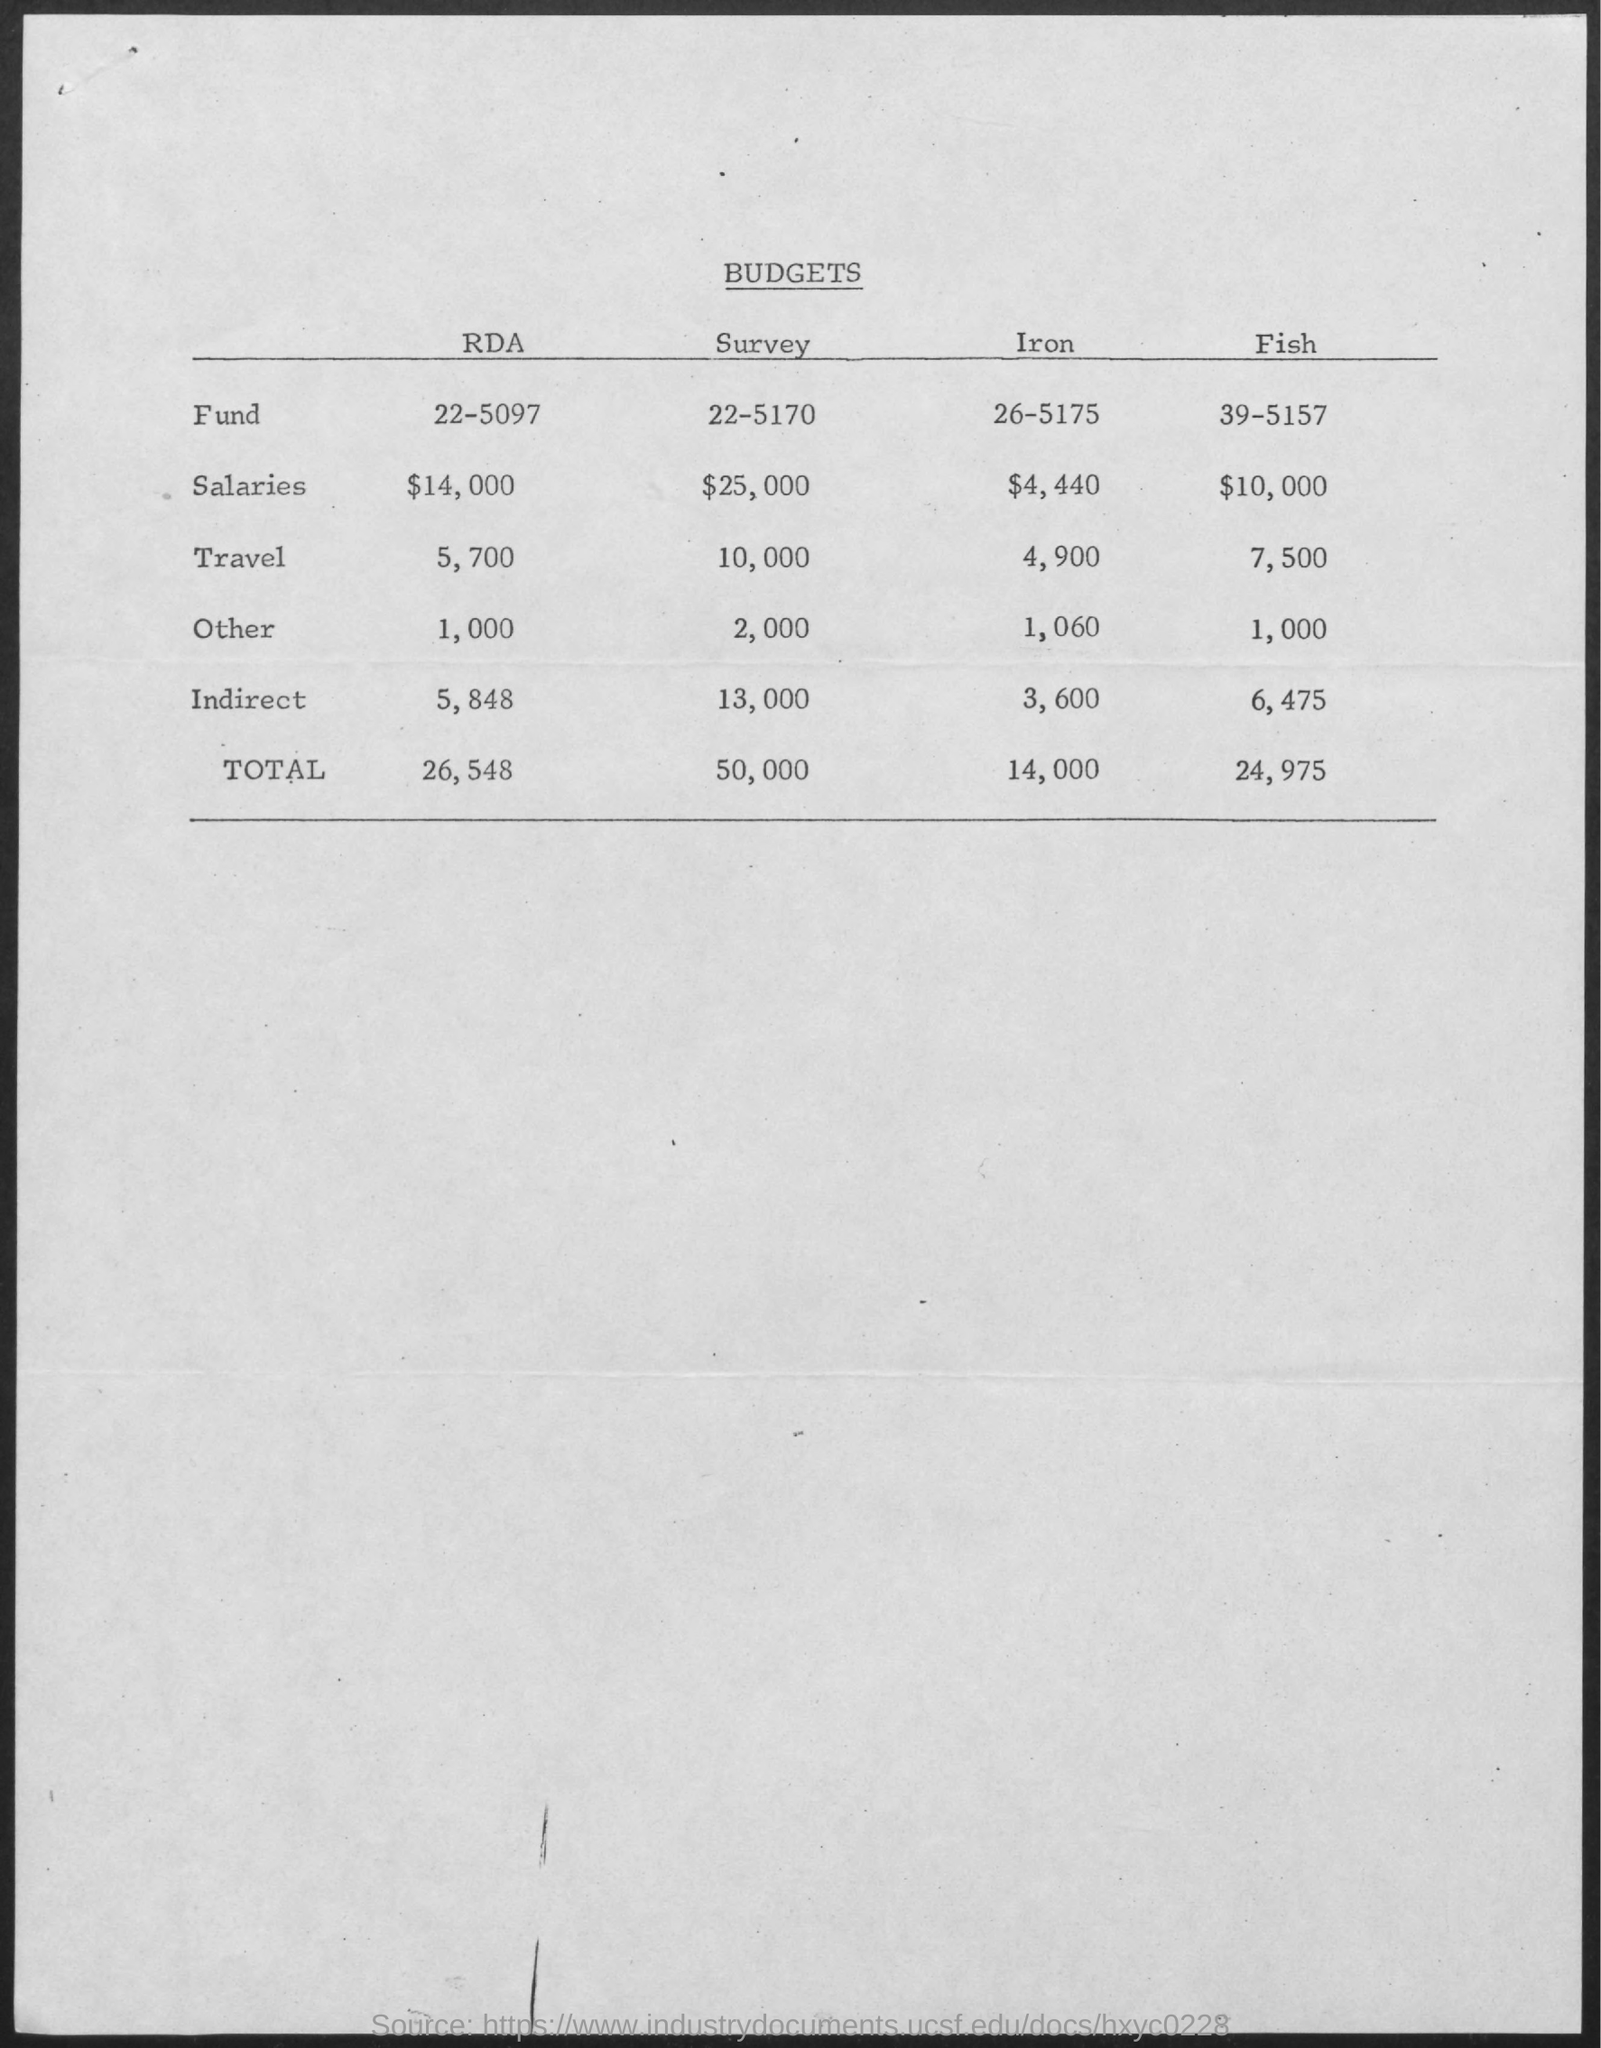What is the Budget for fund for RDA?
Give a very brief answer. 22-5097. What is the Budget for fund for Survey?
Give a very brief answer. 22-5170. What is the Budget for fund for Iron?
Provide a succinct answer. 26-5175. What is the Budget for fund for Fish?
Give a very brief answer. 39-5157. What is the Budget for Salaries for RDA?
Your answer should be compact. $14,000. What is the Budget for Salaries for Survey?
Provide a succinct answer. $25,000. What is the Budget for Salaries for Iron?
Keep it short and to the point. $4,440. What is the Budget for Salaries for Fish?
Offer a very short reply. $10,000. What is the Budget for Travel for RDA?
Make the answer very short. 5,700. What is the Budget for Travel for Survey?
Your answer should be very brief. 10,000. 